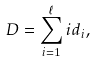Convert formula to latex. <formula><loc_0><loc_0><loc_500><loc_500>D = \sum _ { i = 1 } ^ { \ell } i d _ { i } ,</formula> 